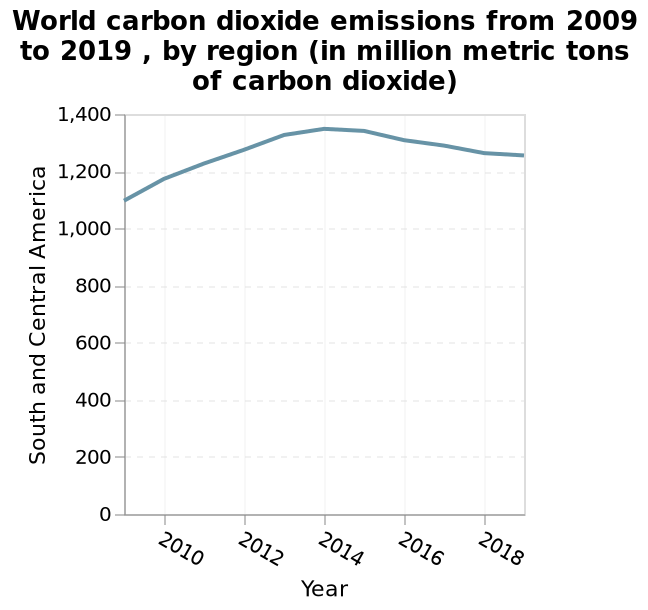<image>
What is the time period covered by the line diagram?  The line diagram covers the time period from 2009 to 2019. please enumerates aspects of the construction of the chart World carbon dioxide emissions from 2009 to 2019 , by region (in million metric tons of carbon dioxide) is a line diagram. The y-axis measures South and Central America. A linear scale from 2010 to 2018 can be found along the x-axis, labeled Year. Which regions are represented in the diagram?  The diagram represents world carbon dioxide emissions from 2009 to 2019 by region, including South and Central America. What was the highest recorded CO2 emission level during the 10-year period from 2009 to 2019 in South and Central America? The highest recorded CO2 emission level during the 10-year period from 2009 to 2019 in South and Central America was 1,350 million metric tons. Does the diagram inaccurately represent world carbon dioxide emissions from 2009 to 2019 by region, excluding South and Central America? No. The diagram represents world carbon dioxide emissions from 2009 to 2019 by region, including South and Central America. 